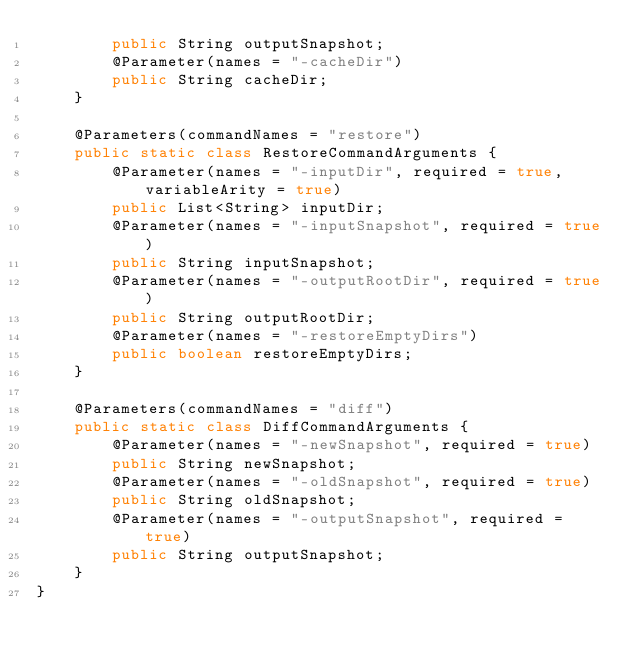<code> <loc_0><loc_0><loc_500><loc_500><_Java_>        public String outputSnapshot;
        @Parameter(names = "-cacheDir")
        public String cacheDir;
    }

    @Parameters(commandNames = "restore")
    public static class RestoreCommandArguments {
        @Parameter(names = "-inputDir", required = true, variableArity = true)
        public List<String> inputDir;
        @Parameter(names = "-inputSnapshot", required = true)
        public String inputSnapshot;
        @Parameter(names = "-outputRootDir", required = true)
        public String outputRootDir;
        @Parameter(names = "-restoreEmptyDirs")
        public boolean restoreEmptyDirs;
    }

    @Parameters(commandNames = "diff")
    public static class DiffCommandArguments {
        @Parameter(names = "-newSnapshot", required = true)
        public String newSnapshot;
        @Parameter(names = "-oldSnapshot", required = true)
        public String oldSnapshot;
        @Parameter(names = "-outputSnapshot", required = true)
        public String outputSnapshot;
    }
}
</code> 